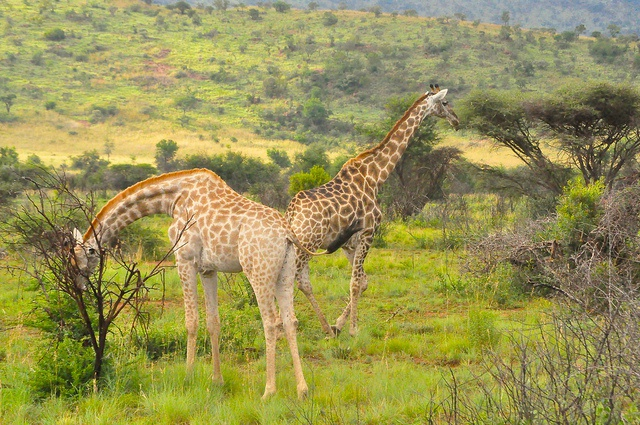Describe the objects in this image and their specific colors. I can see giraffe in darkgray and tan tones and giraffe in darkgray, tan, gray, and olive tones in this image. 